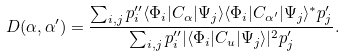<formula> <loc_0><loc_0><loc_500><loc_500>D ( \alpha , { \alpha ^ { \prime } } ) = { \frac { \sum _ { i , j } p _ { i } ^ { \prime \prime } \langle \Phi _ { i } | C _ { \alpha } | \Psi _ { j } \rangle \langle \Phi _ { i } | C _ { \alpha ^ { \prime } } | \Psi _ { j } \rangle ^ { * } p _ { j } ^ { \prime } } { \sum _ { i , j } p _ { i } ^ { \prime \prime } | \langle \Phi _ { i } | C _ { u } | \Psi _ { j } \rangle | ^ { 2 } p _ { j } ^ { \prime } } } .</formula> 